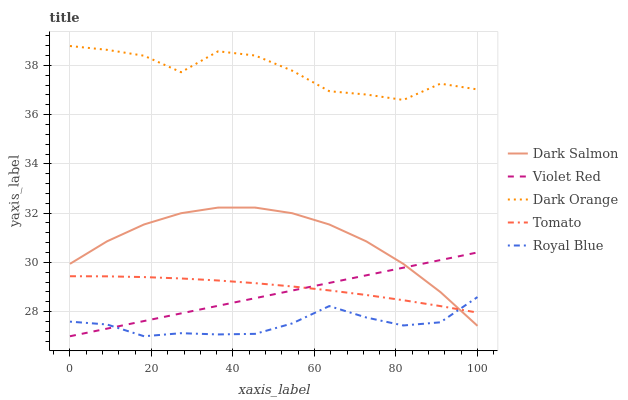Does Royal Blue have the minimum area under the curve?
Answer yes or no. Yes. Does Dark Orange have the maximum area under the curve?
Answer yes or no. Yes. Does Violet Red have the minimum area under the curve?
Answer yes or no. No. Does Violet Red have the maximum area under the curve?
Answer yes or no. No. Is Violet Red the smoothest?
Answer yes or no. Yes. Is Dark Orange the roughest?
Answer yes or no. Yes. Is Dark Orange the smoothest?
Answer yes or no. No. Is Violet Red the roughest?
Answer yes or no. No. Does Violet Red have the lowest value?
Answer yes or no. Yes. Does Dark Orange have the lowest value?
Answer yes or no. No. Does Dark Orange have the highest value?
Answer yes or no. Yes. Does Violet Red have the highest value?
Answer yes or no. No. Is Violet Red less than Dark Orange?
Answer yes or no. Yes. Is Dark Orange greater than Tomato?
Answer yes or no. Yes. Does Violet Red intersect Royal Blue?
Answer yes or no. Yes. Is Violet Red less than Royal Blue?
Answer yes or no. No. Is Violet Red greater than Royal Blue?
Answer yes or no. No. Does Violet Red intersect Dark Orange?
Answer yes or no. No. 